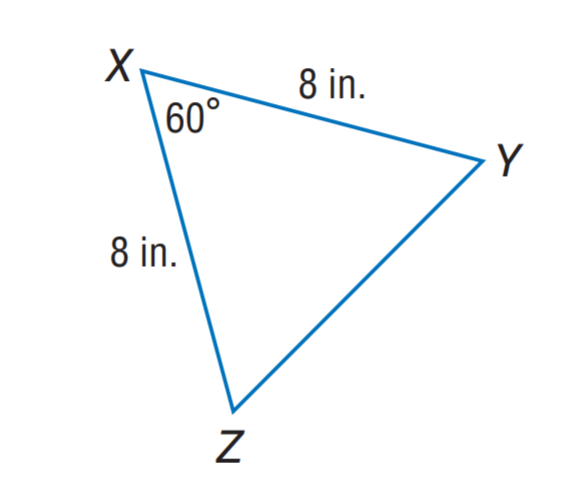Answer the mathemtical geometry problem and directly provide the correct option letter.
Question: Find Y Z.
Choices: A: 6 B: 7 C: 8 D: 9 C 